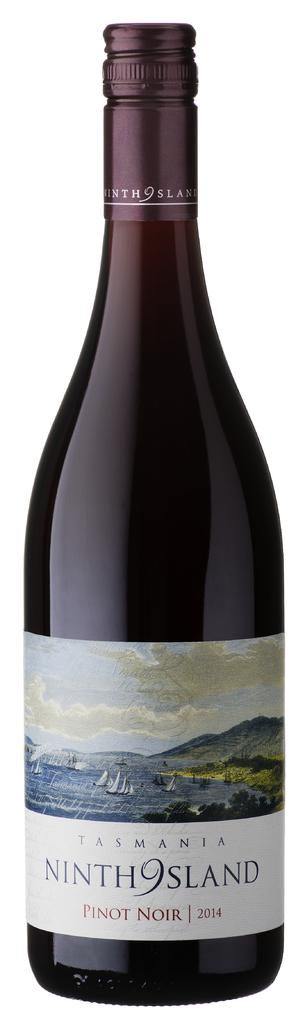<image>
Present a compact description of the photo's key features. A bottle of 9th island pinot noir from 2014 